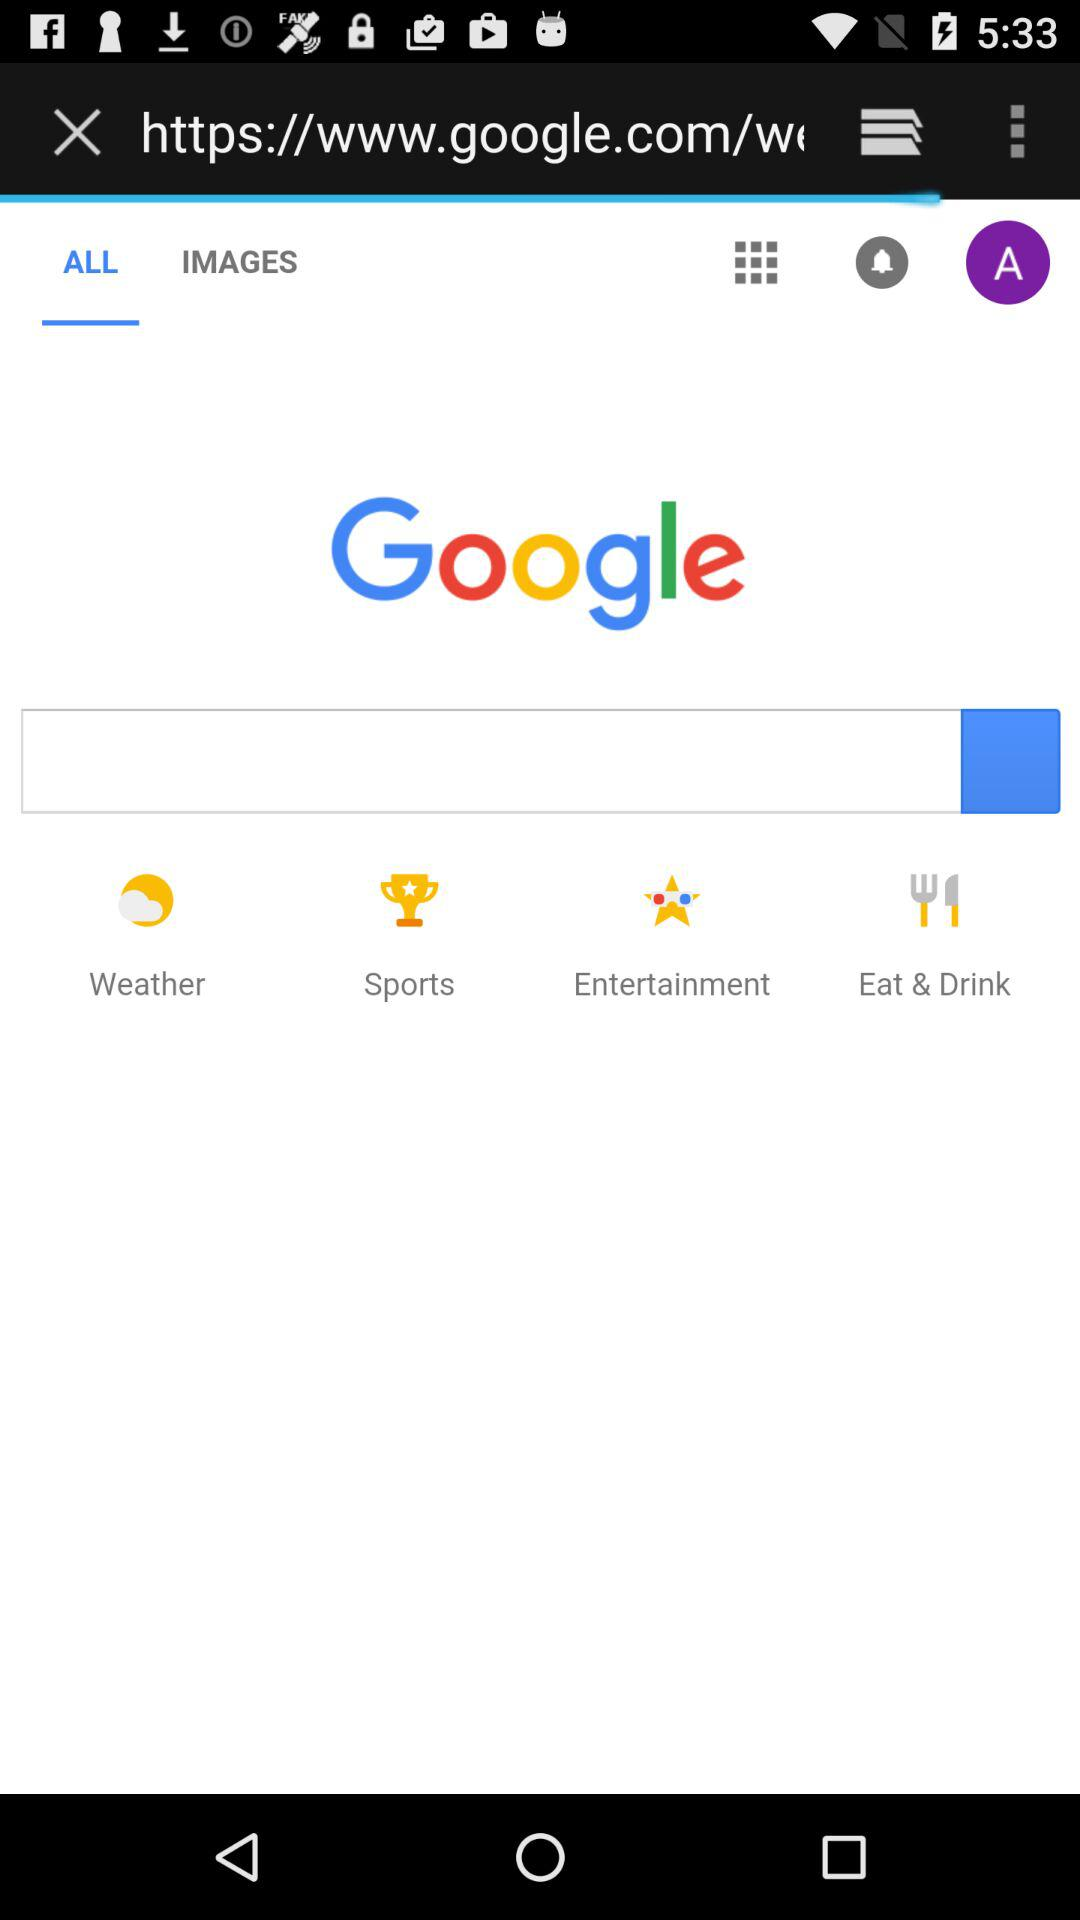Is the user logged in?
When the provided information is insufficient, respond with <no answer>. <no answer> 